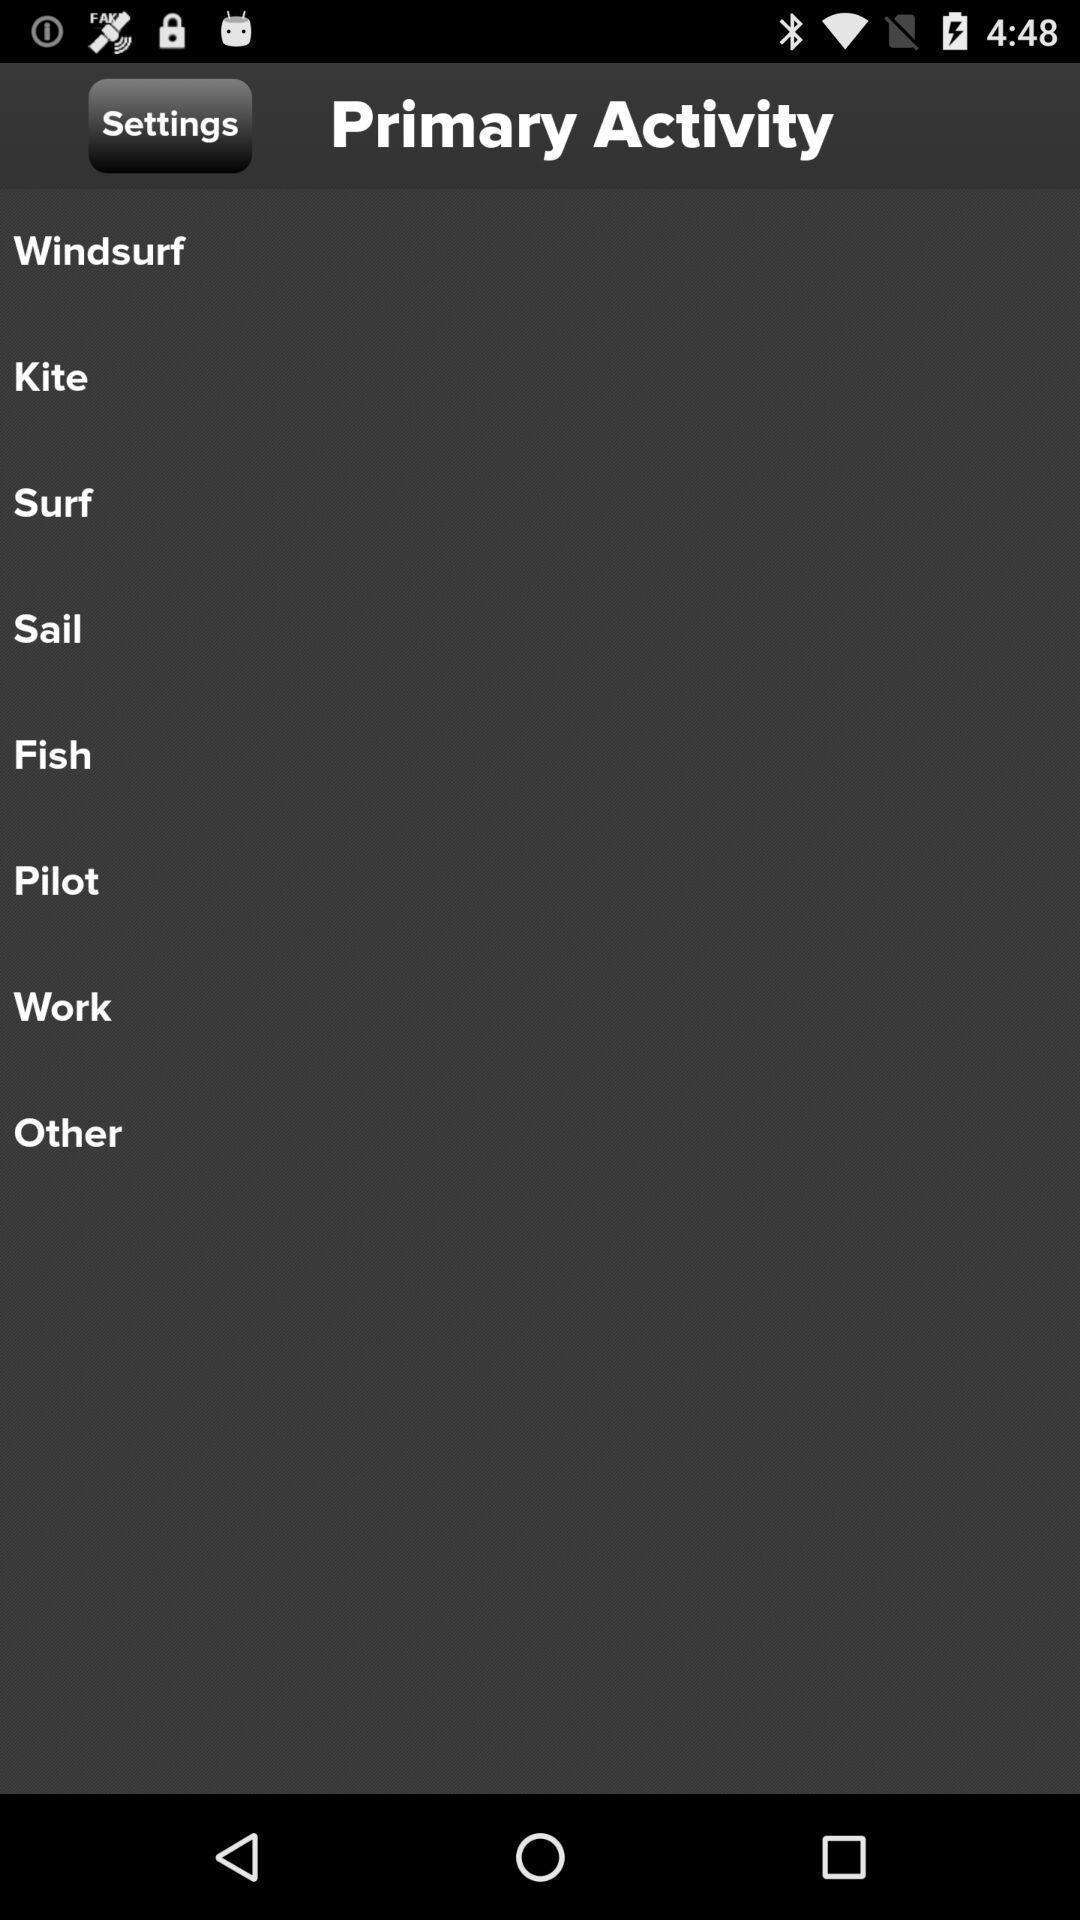Describe the visual elements of this screenshot. Screen showing different primary activities. 